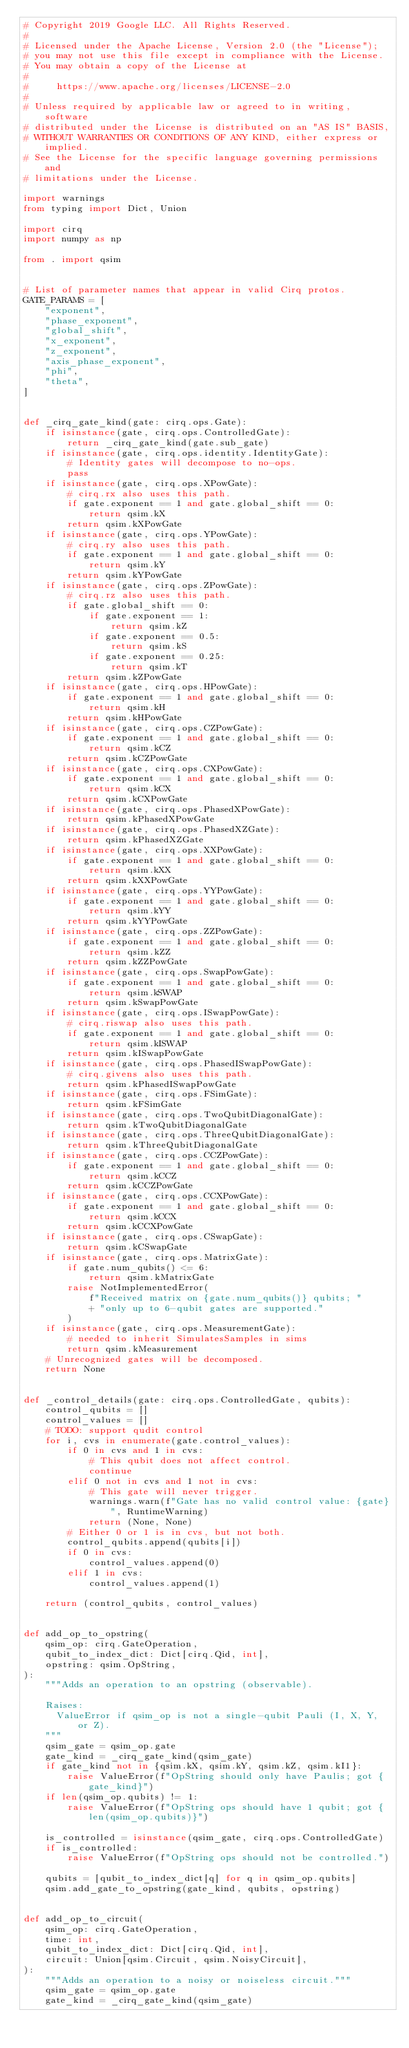Convert code to text. <code><loc_0><loc_0><loc_500><loc_500><_Python_># Copyright 2019 Google LLC. All Rights Reserved.
#
# Licensed under the Apache License, Version 2.0 (the "License");
# you may not use this file except in compliance with the License.
# You may obtain a copy of the License at
#
#     https://www.apache.org/licenses/LICENSE-2.0
#
# Unless required by applicable law or agreed to in writing, software
# distributed under the License is distributed on an "AS IS" BASIS,
# WITHOUT WARRANTIES OR CONDITIONS OF ANY KIND, either express or implied.
# See the License for the specific language governing permissions and
# limitations under the License.

import warnings
from typing import Dict, Union

import cirq
import numpy as np

from . import qsim


# List of parameter names that appear in valid Cirq protos.
GATE_PARAMS = [
    "exponent",
    "phase_exponent",
    "global_shift",
    "x_exponent",
    "z_exponent",
    "axis_phase_exponent",
    "phi",
    "theta",
]


def _cirq_gate_kind(gate: cirq.ops.Gate):
    if isinstance(gate, cirq.ops.ControlledGate):
        return _cirq_gate_kind(gate.sub_gate)
    if isinstance(gate, cirq.ops.identity.IdentityGate):
        # Identity gates will decompose to no-ops.
        pass
    if isinstance(gate, cirq.ops.XPowGate):
        # cirq.rx also uses this path.
        if gate.exponent == 1 and gate.global_shift == 0:
            return qsim.kX
        return qsim.kXPowGate
    if isinstance(gate, cirq.ops.YPowGate):
        # cirq.ry also uses this path.
        if gate.exponent == 1 and gate.global_shift == 0:
            return qsim.kY
        return qsim.kYPowGate
    if isinstance(gate, cirq.ops.ZPowGate):
        # cirq.rz also uses this path.
        if gate.global_shift == 0:
            if gate.exponent == 1:
                return qsim.kZ
            if gate.exponent == 0.5:
                return qsim.kS
            if gate.exponent == 0.25:
                return qsim.kT
        return qsim.kZPowGate
    if isinstance(gate, cirq.ops.HPowGate):
        if gate.exponent == 1 and gate.global_shift == 0:
            return qsim.kH
        return qsim.kHPowGate
    if isinstance(gate, cirq.ops.CZPowGate):
        if gate.exponent == 1 and gate.global_shift == 0:
            return qsim.kCZ
        return qsim.kCZPowGate
    if isinstance(gate, cirq.ops.CXPowGate):
        if gate.exponent == 1 and gate.global_shift == 0:
            return qsim.kCX
        return qsim.kCXPowGate
    if isinstance(gate, cirq.ops.PhasedXPowGate):
        return qsim.kPhasedXPowGate
    if isinstance(gate, cirq.ops.PhasedXZGate):
        return qsim.kPhasedXZGate
    if isinstance(gate, cirq.ops.XXPowGate):
        if gate.exponent == 1 and gate.global_shift == 0:
            return qsim.kXX
        return qsim.kXXPowGate
    if isinstance(gate, cirq.ops.YYPowGate):
        if gate.exponent == 1 and gate.global_shift == 0:
            return qsim.kYY
        return qsim.kYYPowGate
    if isinstance(gate, cirq.ops.ZZPowGate):
        if gate.exponent == 1 and gate.global_shift == 0:
            return qsim.kZZ
        return qsim.kZZPowGate
    if isinstance(gate, cirq.ops.SwapPowGate):
        if gate.exponent == 1 and gate.global_shift == 0:
            return qsim.kSWAP
        return qsim.kSwapPowGate
    if isinstance(gate, cirq.ops.ISwapPowGate):
        # cirq.riswap also uses this path.
        if gate.exponent == 1 and gate.global_shift == 0:
            return qsim.kISWAP
        return qsim.kISwapPowGate
    if isinstance(gate, cirq.ops.PhasedISwapPowGate):
        # cirq.givens also uses this path.
        return qsim.kPhasedISwapPowGate
    if isinstance(gate, cirq.ops.FSimGate):
        return qsim.kFSimGate
    if isinstance(gate, cirq.ops.TwoQubitDiagonalGate):
        return qsim.kTwoQubitDiagonalGate
    if isinstance(gate, cirq.ops.ThreeQubitDiagonalGate):
        return qsim.kThreeQubitDiagonalGate
    if isinstance(gate, cirq.ops.CCZPowGate):
        if gate.exponent == 1 and gate.global_shift == 0:
            return qsim.kCCZ
        return qsim.kCCZPowGate
    if isinstance(gate, cirq.ops.CCXPowGate):
        if gate.exponent == 1 and gate.global_shift == 0:
            return qsim.kCCX
        return qsim.kCCXPowGate
    if isinstance(gate, cirq.ops.CSwapGate):
        return qsim.kCSwapGate
    if isinstance(gate, cirq.ops.MatrixGate):
        if gate.num_qubits() <= 6:
            return qsim.kMatrixGate
        raise NotImplementedError(
            f"Received matrix on {gate.num_qubits()} qubits; "
            + "only up to 6-qubit gates are supported."
        )
    if isinstance(gate, cirq.ops.MeasurementGate):
        # needed to inherit SimulatesSamples in sims
        return qsim.kMeasurement
    # Unrecognized gates will be decomposed.
    return None


def _control_details(gate: cirq.ops.ControlledGate, qubits):
    control_qubits = []
    control_values = []
    # TODO: support qudit control
    for i, cvs in enumerate(gate.control_values):
        if 0 in cvs and 1 in cvs:
            # This qubit does not affect control.
            continue
        elif 0 not in cvs and 1 not in cvs:
            # This gate will never trigger.
            warnings.warn(f"Gate has no valid control value: {gate}", RuntimeWarning)
            return (None, None)
        # Either 0 or 1 is in cvs, but not both.
        control_qubits.append(qubits[i])
        if 0 in cvs:
            control_values.append(0)
        elif 1 in cvs:
            control_values.append(1)

    return (control_qubits, control_values)


def add_op_to_opstring(
    qsim_op: cirq.GateOperation,
    qubit_to_index_dict: Dict[cirq.Qid, int],
    opstring: qsim.OpString,
):
    """Adds an operation to an opstring (observable).

    Raises:
      ValueError if qsim_op is not a single-qubit Pauli (I, X, Y, or Z).
    """
    qsim_gate = qsim_op.gate
    gate_kind = _cirq_gate_kind(qsim_gate)
    if gate_kind not in {qsim.kX, qsim.kY, qsim.kZ, qsim.kI1}:
        raise ValueError(f"OpString should only have Paulis; got {gate_kind}")
    if len(qsim_op.qubits) != 1:
        raise ValueError(f"OpString ops should have 1 qubit; got {len(qsim_op.qubits)}")

    is_controlled = isinstance(qsim_gate, cirq.ops.ControlledGate)
    if is_controlled:
        raise ValueError(f"OpString ops should not be controlled.")

    qubits = [qubit_to_index_dict[q] for q in qsim_op.qubits]
    qsim.add_gate_to_opstring(gate_kind, qubits, opstring)


def add_op_to_circuit(
    qsim_op: cirq.GateOperation,
    time: int,
    qubit_to_index_dict: Dict[cirq.Qid, int],
    circuit: Union[qsim.Circuit, qsim.NoisyCircuit],
):
    """Adds an operation to a noisy or noiseless circuit."""
    qsim_gate = qsim_op.gate
    gate_kind = _cirq_gate_kind(qsim_gate)</code> 